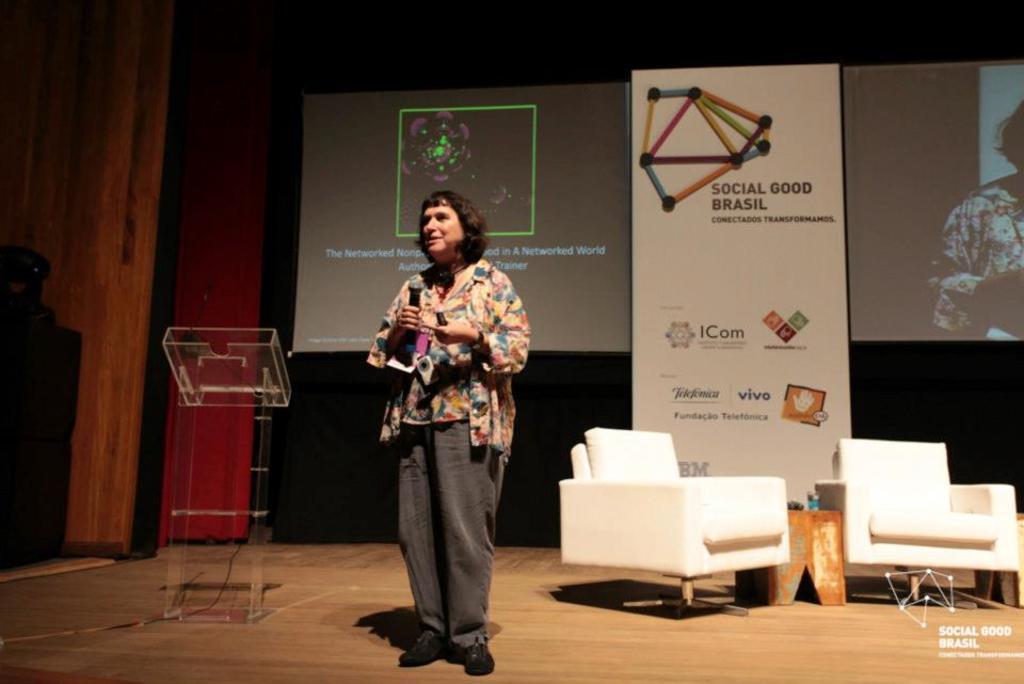How would you summarize this image in a sentence or two? In the image there is woman standing on dais holding microphone in her hand. Beside her there is podium. To the right corner of the image there are couches and between there is a small table. Behind the woman there are two projector boards on which text is displayed. In the background there is a board and wall. At the below right corner of the image there is logo and text. 